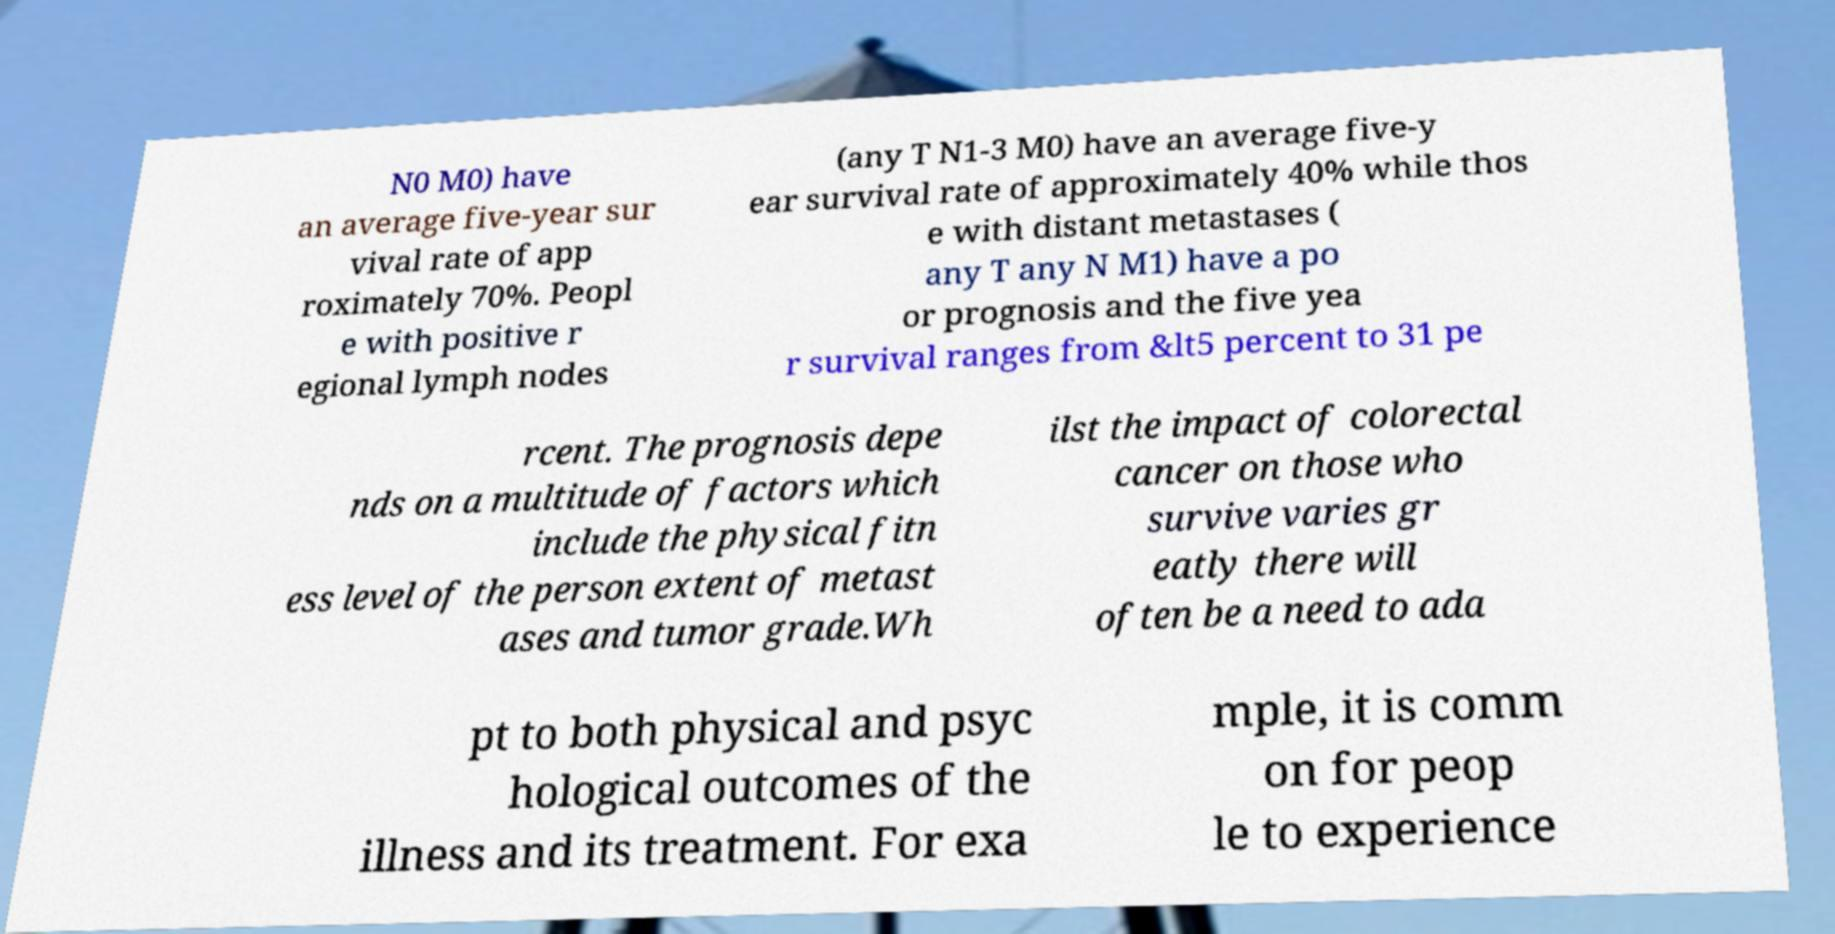For documentation purposes, I need the text within this image transcribed. Could you provide that? N0 M0) have an average five-year sur vival rate of app roximately 70%. Peopl e with positive r egional lymph nodes (any T N1-3 M0) have an average five-y ear survival rate of approximately 40% while thos e with distant metastases ( any T any N M1) have a po or prognosis and the five yea r survival ranges from &lt5 percent to 31 pe rcent. The prognosis depe nds on a multitude of factors which include the physical fitn ess level of the person extent of metast ases and tumor grade.Wh ilst the impact of colorectal cancer on those who survive varies gr eatly there will often be a need to ada pt to both physical and psyc hological outcomes of the illness and its treatment. For exa mple, it is comm on for peop le to experience 